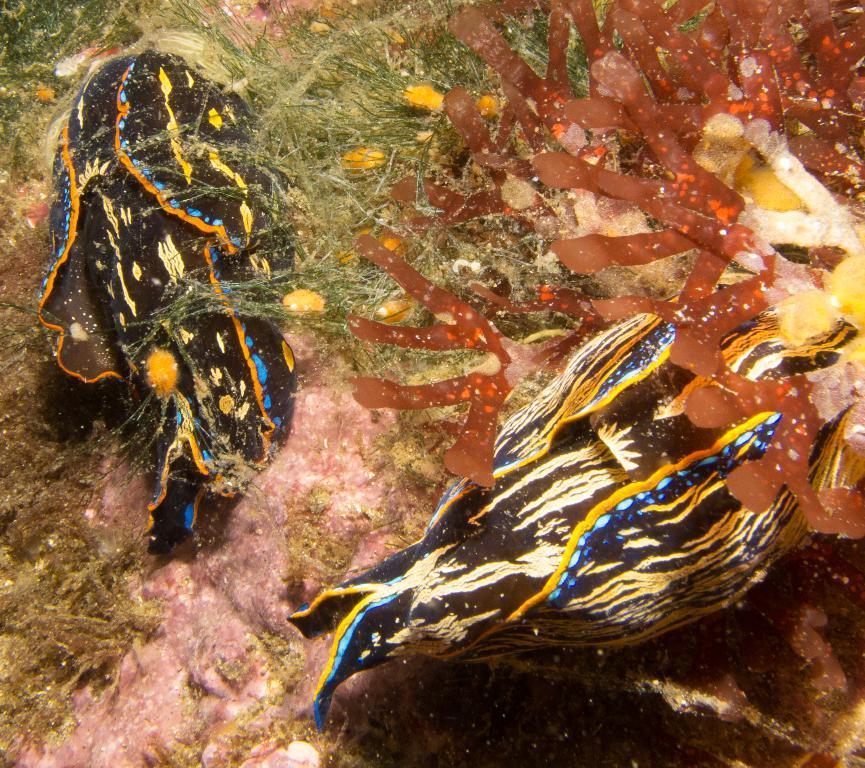Could you give a brief overview of what you see in this image? In this image there are fishes and algae in the water. 